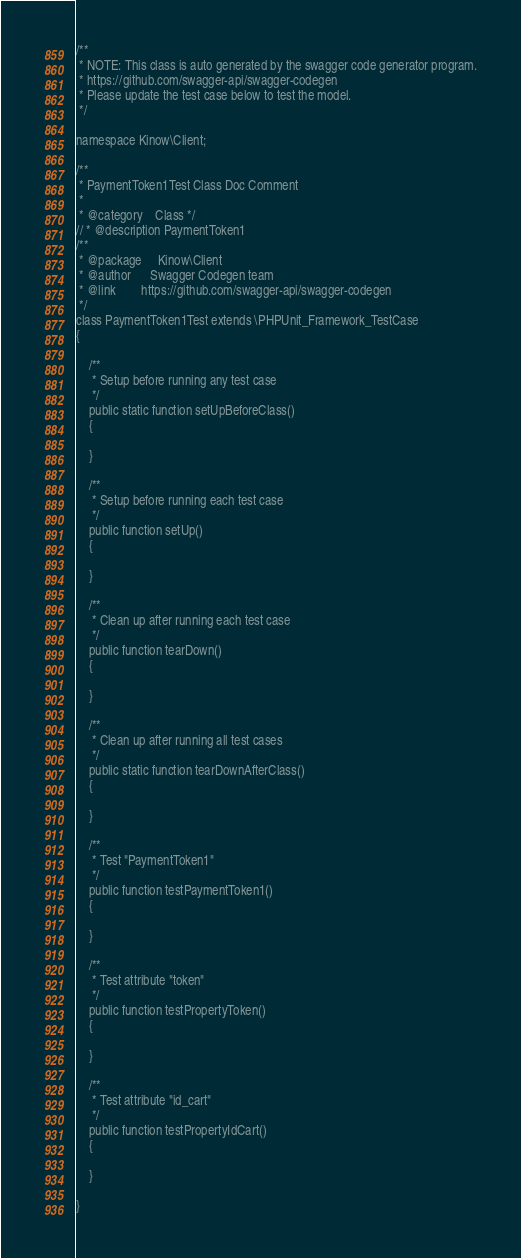Convert code to text. <code><loc_0><loc_0><loc_500><loc_500><_PHP_>/**
 * NOTE: This class is auto generated by the swagger code generator program.
 * https://github.com/swagger-api/swagger-codegen
 * Please update the test case below to test the model.
 */

namespace Kinow\Client;

/**
 * PaymentToken1Test Class Doc Comment
 *
 * @category    Class */
// * @description PaymentToken1
/**
 * @package     Kinow\Client
 * @author      Swagger Codegen team
 * @link        https://github.com/swagger-api/swagger-codegen
 */
class PaymentToken1Test extends \PHPUnit_Framework_TestCase
{

    /**
     * Setup before running any test case
     */
    public static function setUpBeforeClass()
    {

    }

    /**
     * Setup before running each test case
     */
    public function setUp()
    {

    }

    /**
     * Clean up after running each test case
     */
    public function tearDown()
    {

    }

    /**
     * Clean up after running all test cases
     */
    public static function tearDownAfterClass()
    {

    }

    /**
     * Test "PaymentToken1"
     */
    public function testPaymentToken1()
    {

    }

    /**
     * Test attribute "token"
     */
    public function testPropertyToken()
    {

    }

    /**
     * Test attribute "id_cart"
     */
    public function testPropertyIdCart()
    {

    }

}
</code> 